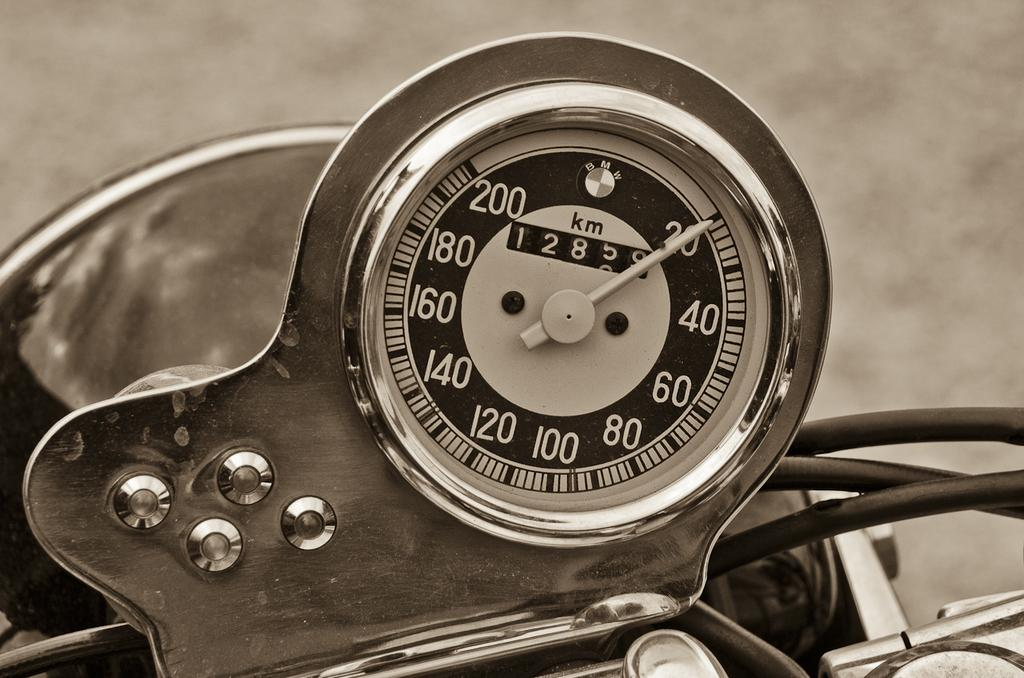What is the main object on the vehicle in the image? There is a display meter on a vehicle in the image. What information can be seen on the display meter? The display meter has numbers and alphabets. Can you describe the background of the image? The background of the image is blurry. What type of boot is being used to guide the argument in the image? There is no boot, guide, or argument present in the image. 